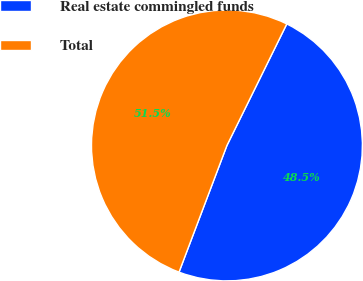<chart> <loc_0><loc_0><loc_500><loc_500><pie_chart><fcel>Real estate commingled funds<fcel>Total<nl><fcel>48.47%<fcel>51.53%<nl></chart> 